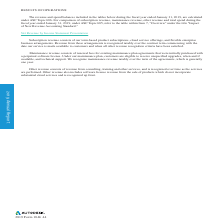Looking at Autodesk's financial data, please calculate: What is the percentage of total revenue that comes from unbilled deferred revenue as of January 31, 2018? Based on the calculation: (326.4/2,281.5) , the result is 14.31 (percentage). The key data points involved are: 2,281.5, 326.4. Also, can you calculate: What is the difference between the unbilled deferred revenue for ASC 605 from January 31, 2018 to January 31, 2019? Based on the calculation: 491.6-326.4 , the result is 165.2 (in millions). The key data points involved are: 326.4, 491.6. Also, What are possible reasons that the amount of billed and unbilled deferred revenue will change from quarter to quarter? Based on the financial document, the answer is amount of billed and unbilled deferred revenue will change from quarter to quarter for several reasons, including the specific timing, duration and size of customer subscription and support agreements, varying billing cycles of such agreements, the specific timing of customer renewals, and foreign currency fluctuations. Also, What is the difference between ASC 605 and ASC 606 in fiscal year 2019? The document shows two values: The adoption of ASC Topic 606 required a change to the definition of unbilled deferred revenue and new qualitative and quantitative disclosures around our performance obligations. and Under ASC Topic 606, unbilled deferred revenue is not included as a receivable or deferred revenue on our Consolidated Balance Sheet.. Also, What is the unbilled deferred revenue as of January 31, 2018?  Based on the financial document, the answer is 326.4 (in millions). Also, can you calculate: What is the average deferred revenue from 2018 to 2019 under ASC 605? To answer this question, I need to perform calculations using the financial data. The calculation is: (2,269.2+1,955.1)/2 , which equals 2112.15 (in millions). The key data points involved are: 1,955.1, 2,269.2. 